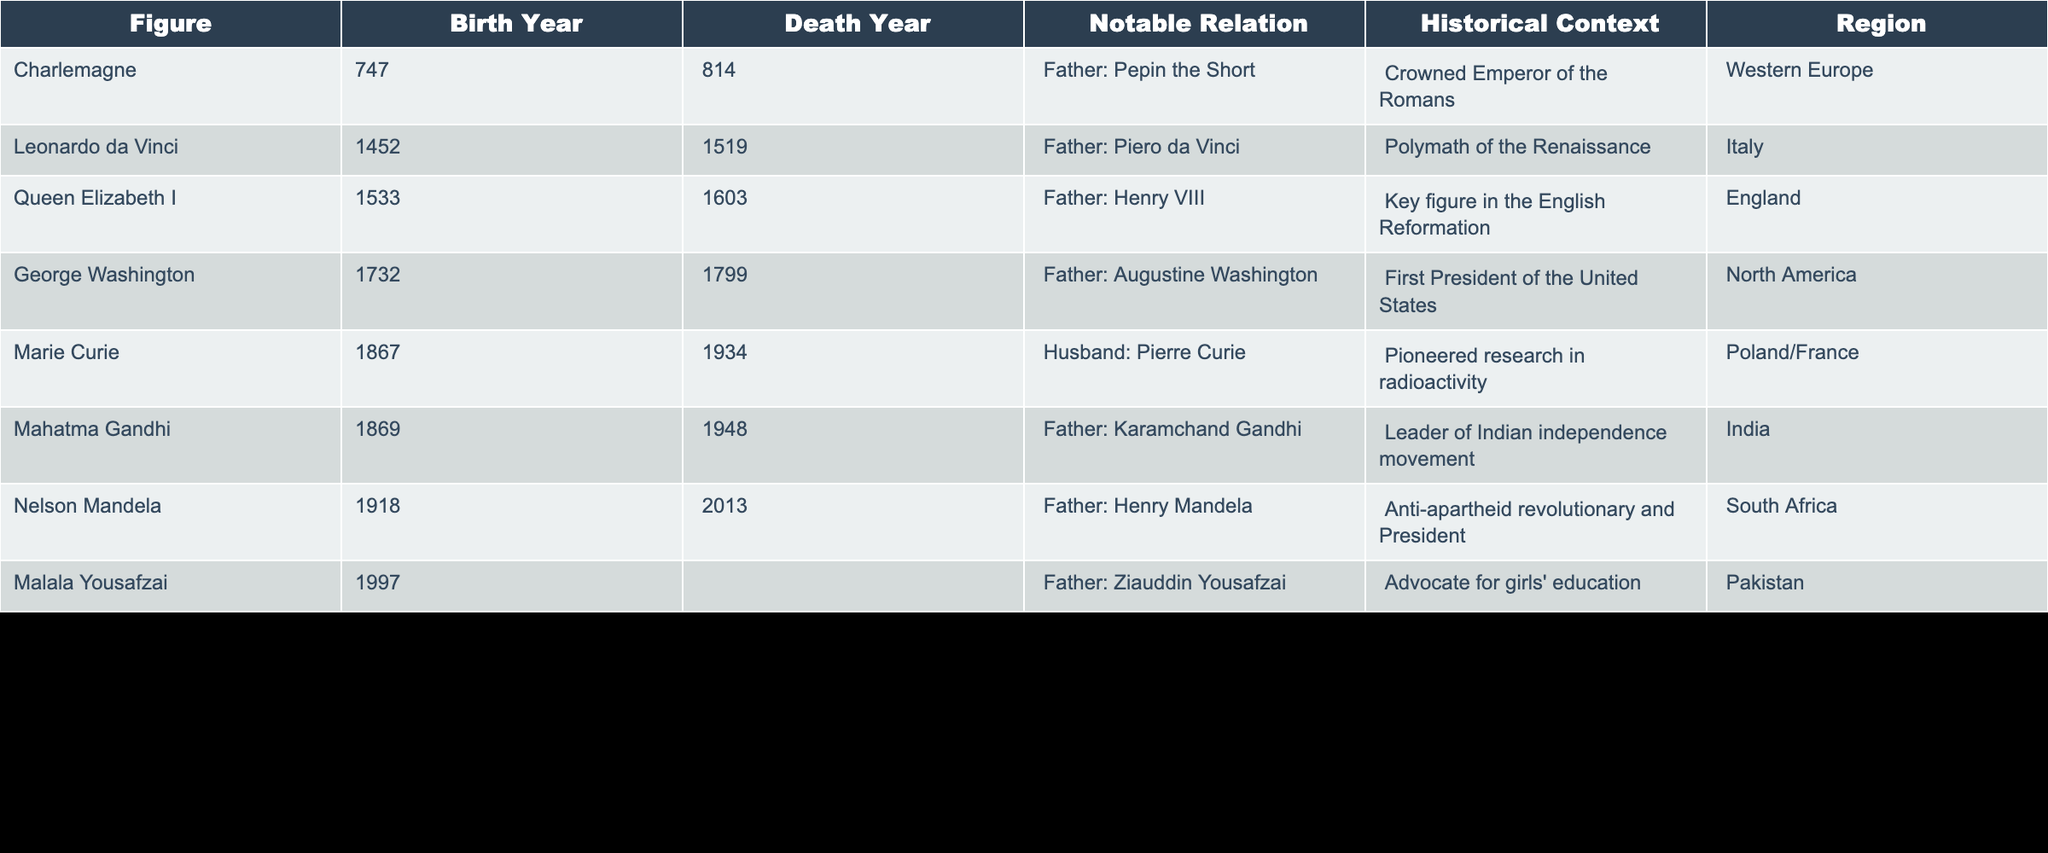What was the birth year of Mahatma Gandhi? From the table, the column for Birth Year lists Mahatma Gandhi's birth year as 1869.
Answer: 1869 Which notable figure is associated with the historical context of the English Reformation? The table specifies that Queen Elizabeth I, with Father Henry VIII, is a key figure in the English Reformation.
Answer: Queen Elizabeth I Is Marie Curie from North America? According to the table, Marie Curie's listed region is Poland/France, which indicates she is not from North America.
Answer: No Who is the notable relation of Leonardo da Vinci? The table shows that Leonardo da Vinci's father is Piero da Vinci.
Answer: Piero da Vinci How many figures in the table were born in the 19th century? The figures listed who were born in the 19th century are Marie Curie (1867), Mahatma Gandhi (1869), totaling 2 figures.
Answer: 2 Which figure is recognized as the first President of the United States? The table identifies George Washington, with Father Augustine Washington, as the first President of the United States.
Answer: George Washington What is the average birth year of the figures listed in the table? The birth years are 747, 1452, 1533, 1732, 1867, 1869, 1918, and 1997. Adding these gives a total of 9734. Since there are 8 figures, the average is 9734/8 = 1216.75. However, since this does not yield a typical birth year, rounding gives approximately 1217.
Answer: 1217 Which of the figures listed in the table had a parent who was a leader? Analyzing the entries, Mahatma Gandhi's father, Karamchand Gandhi, is noted as a leader of the Indian independence movement, making him a notable relation of a leader.
Answer: Mahatma Gandhi Is there any figure listed who has no recorded death year? In the table, Malala Yousafzai is listed with an empty space for the death year, indicating no recorded death year.
Answer: Yes 